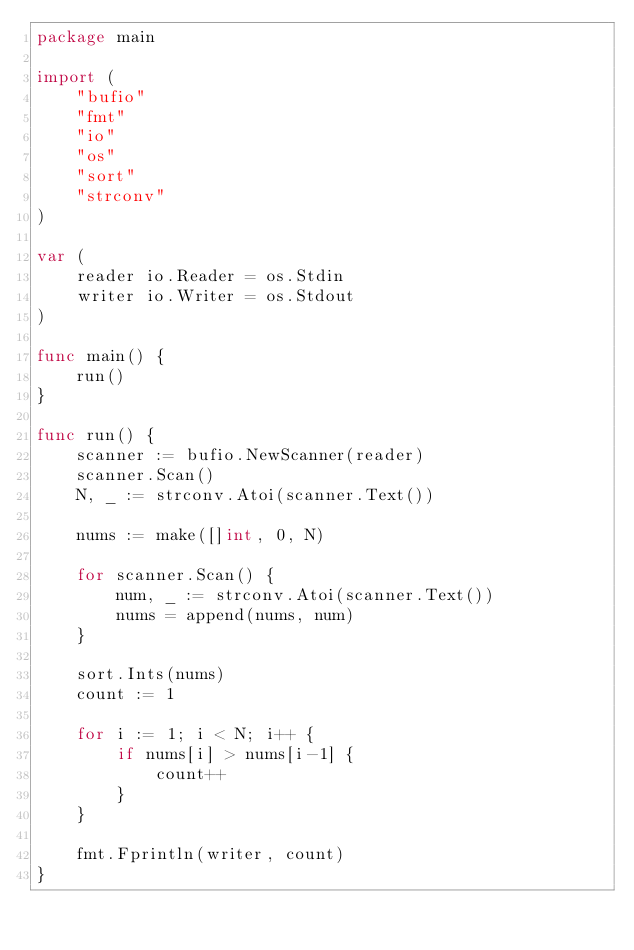<code> <loc_0><loc_0><loc_500><loc_500><_Go_>package main

import (
	"bufio"
	"fmt"
	"io"
	"os"
	"sort"
	"strconv"
)

var (
	reader io.Reader = os.Stdin
	writer io.Writer = os.Stdout
)

func main() {
	run()
}

func run() {
	scanner := bufio.NewScanner(reader)
	scanner.Scan()
	N, _ := strconv.Atoi(scanner.Text())

	nums := make([]int, 0, N)

	for scanner.Scan() {
		num, _ := strconv.Atoi(scanner.Text())
		nums = append(nums, num)
	}

	sort.Ints(nums)
	count := 1

	for i := 1; i < N; i++ {
		if nums[i] > nums[i-1] {
			count++
		}
	}

	fmt.Fprintln(writer, count)
}
</code> 